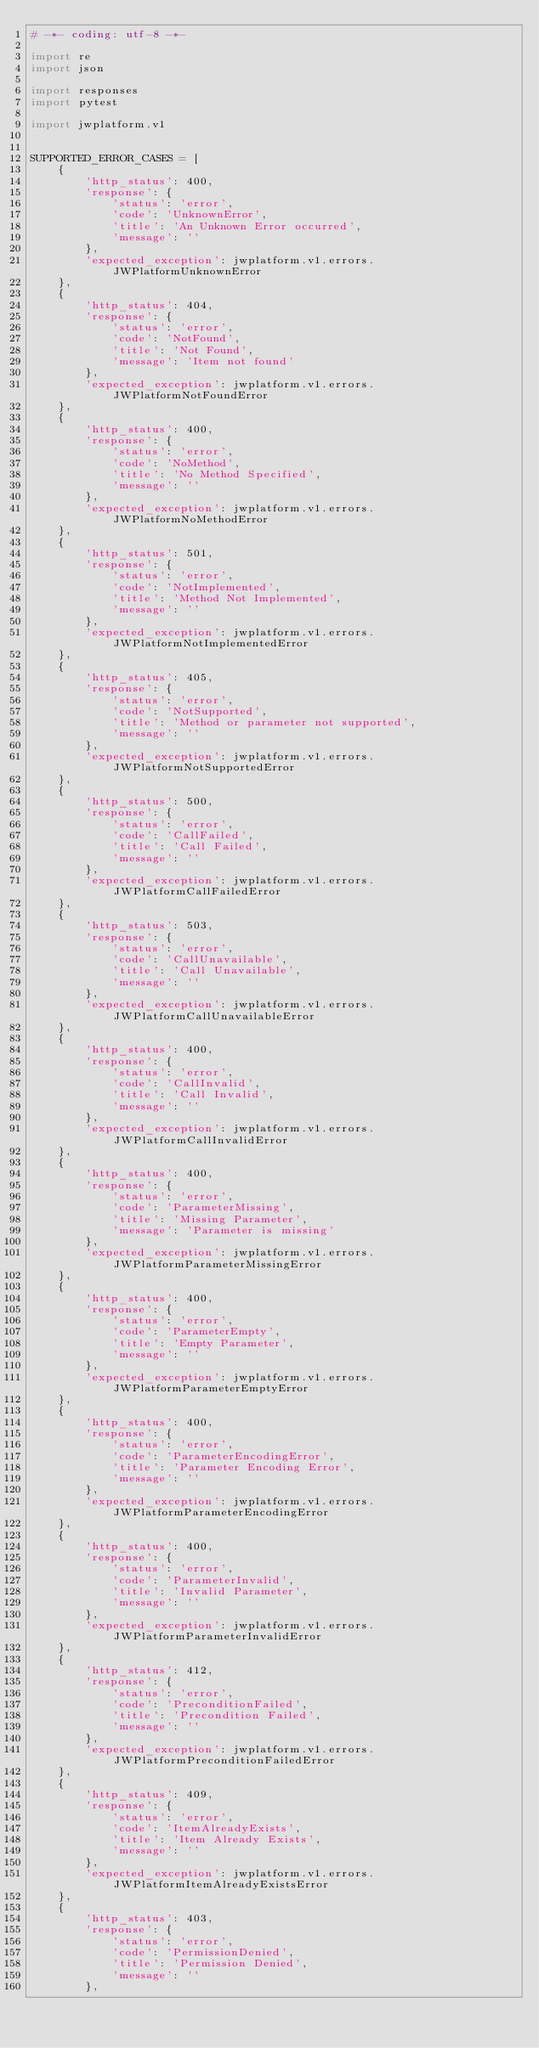<code> <loc_0><loc_0><loc_500><loc_500><_Python_># -*- coding: utf-8 -*-

import re
import json

import responses
import pytest

import jwplatform.v1


SUPPORTED_ERROR_CASES = [
    {
        'http_status': 400,
        'response': {
            'status': 'error',
            'code': 'UnknownError',
            'title': 'An Unknown Error occurred',
            'message': ''
        },
        'expected_exception': jwplatform.v1.errors.JWPlatformUnknownError
    },
    {
        'http_status': 404,
        'response': {
            'status': 'error',
            'code': 'NotFound',
            'title': 'Not Found',
            'message': 'Item not found'
        },
        'expected_exception': jwplatform.v1.errors.JWPlatformNotFoundError
    },
    {
        'http_status': 400,
        'response': {
            'status': 'error',
            'code': 'NoMethod',
            'title': 'No Method Specified',
            'message': ''
        },
        'expected_exception': jwplatform.v1.errors.JWPlatformNoMethodError
    },
    {
        'http_status': 501,
        'response': {
            'status': 'error',
            'code': 'NotImplemented',
            'title': 'Method Not Implemented',
            'message': ''
        },
        'expected_exception': jwplatform.v1.errors.JWPlatformNotImplementedError
    },
    {
        'http_status': 405,
        'response': {
            'status': 'error',
            'code': 'NotSupported',
            'title': 'Method or parameter not supported',
            'message': ''
        },
        'expected_exception': jwplatform.v1.errors.JWPlatformNotSupportedError
    },
    {
        'http_status': 500,
        'response': {
            'status': 'error',
            'code': 'CallFailed',
            'title': 'Call Failed',
            'message': ''
        },
        'expected_exception': jwplatform.v1.errors.JWPlatformCallFailedError
    },
    {
        'http_status': 503,
        'response': {
            'status': 'error',
            'code': 'CallUnavailable',
            'title': 'Call Unavailable',
            'message': ''
        },
        'expected_exception': jwplatform.v1.errors.JWPlatformCallUnavailableError
    },
    {
        'http_status': 400,
        'response': {
            'status': 'error',
            'code': 'CallInvalid',
            'title': 'Call Invalid',
            'message': ''
        },
        'expected_exception': jwplatform.v1.errors.JWPlatformCallInvalidError
    },
    {
        'http_status': 400,
        'response': {
            'status': 'error',
            'code': 'ParameterMissing',
            'title': 'Missing Parameter',
            'message': 'Parameter is missing'
        },
        'expected_exception': jwplatform.v1.errors.JWPlatformParameterMissingError
    },
    {
        'http_status': 400,
        'response': {
            'status': 'error',
            'code': 'ParameterEmpty',
            'title': 'Empty Parameter',
            'message': ''
        },
        'expected_exception': jwplatform.v1.errors.JWPlatformParameterEmptyError
    },
    {
        'http_status': 400,
        'response': {
            'status': 'error',
            'code': 'ParameterEncodingError',
            'title': 'Parameter Encoding Error',
            'message': ''
        },
        'expected_exception': jwplatform.v1.errors.JWPlatformParameterEncodingError
    },
    {
        'http_status': 400,
        'response': {
            'status': 'error',
            'code': 'ParameterInvalid',
            'title': 'Invalid Parameter',
            'message': ''
        },
        'expected_exception': jwplatform.v1.errors.JWPlatformParameterInvalidError
    },
    {
        'http_status': 412,
        'response': {
            'status': 'error',
            'code': 'PreconditionFailed',
            'title': 'Precondition Failed',
            'message': ''
        },
        'expected_exception': jwplatform.v1.errors.JWPlatformPreconditionFailedError
    },
    {
        'http_status': 409,
        'response': {
            'status': 'error',
            'code': 'ItemAlreadyExists',
            'title': 'Item Already Exists',
            'message': ''
        },
        'expected_exception': jwplatform.v1.errors.JWPlatformItemAlreadyExistsError
    },
    {
        'http_status': 403,
        'response': {
            'status': 'error',
            'code': 'PermissionDenied',
            'title': 'Permission Denied',
            'message': ''
        },</code> 